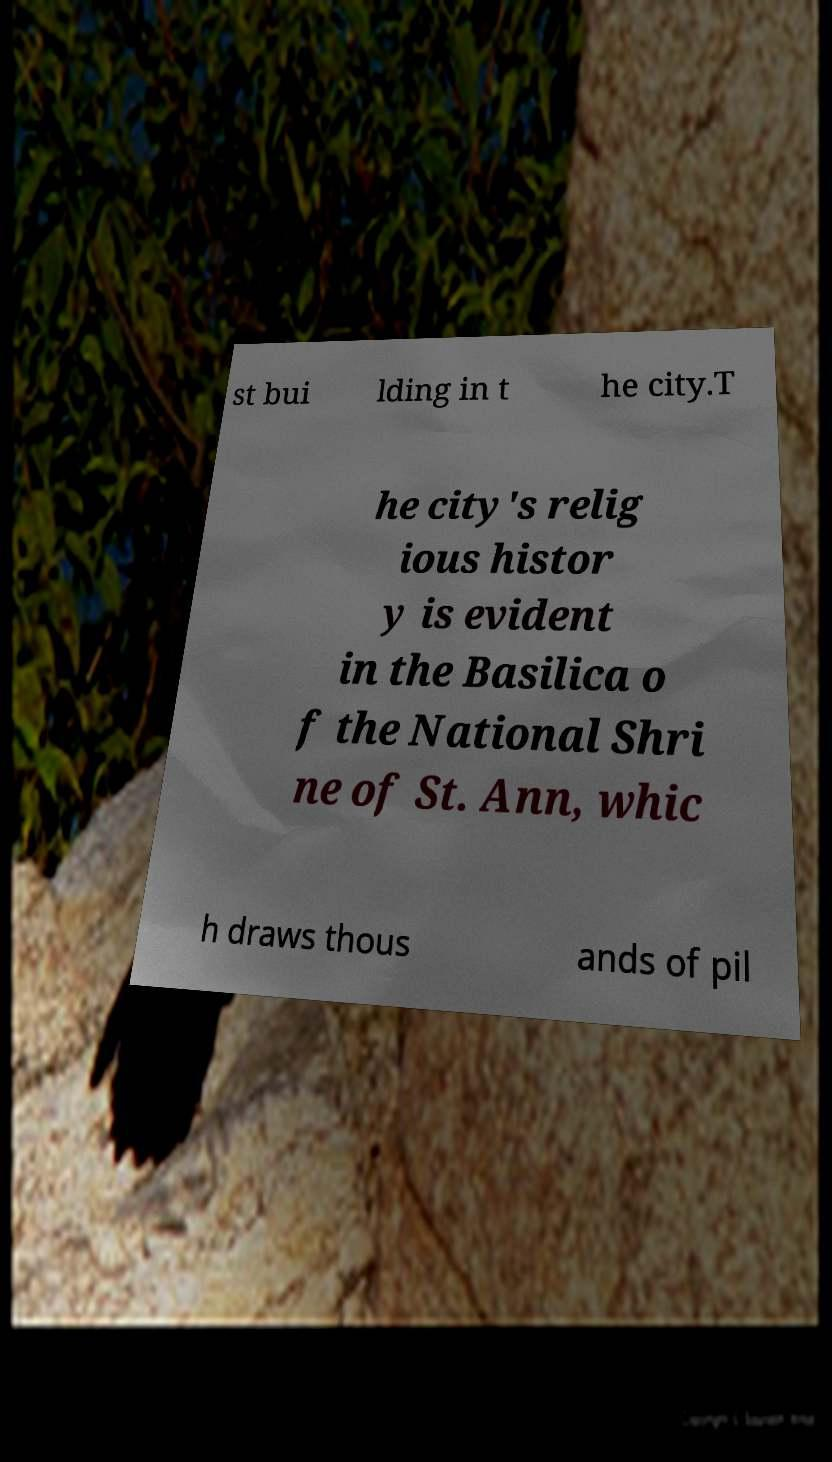I need the written content from this picture converted into text. Can you do that? st bui lding in t he city.T he city's relig ious histor y is evident in the Basilica o f the National Shri ne of St. Ann, whic h draws thous ands of pil 